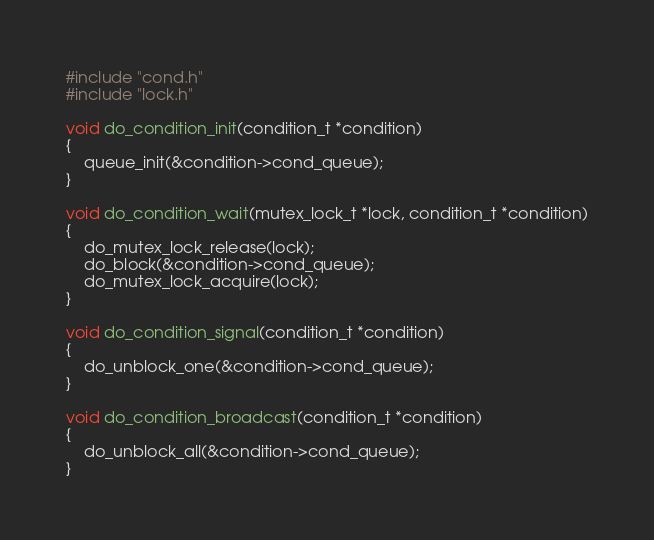<code> <loc_0><loc_0><loc_500><loc_500><_C_>#include "cond.h"
#include "lock.h"

void do_condition_init(condition_t *condition)
{
    queue_init(&condition->cond_queue);
}

void do_condition_wait(mutex_lock_t *lock, condition_t *condition)
{
    do_mutex_lock_release(lock);
    do_block(&condition->cond_queue);
    do_mutex_lock_acquire(lock);
}

void do_condition_signal(condition_t *condition)
{
    do_unblock_one(&condition->cond_queue);
}

void do_condition_broadcast(condition_t *condition)
{
    do_unblock_all(&condition->cond_queue);
}</code> 